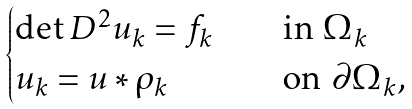Convert formula to latex. <formula><loc_0><loc_0><loc_500><loc_500>\begin{cases} \det D ^ { 2 } u _ { k } = f _ { k } \quad & \text {in $\Omega_{k}$} \\ u _ { k } = u \ast \rho _ { k } & \text {on $\partial \Omega_{k}$,} \end{cases}</formula> 